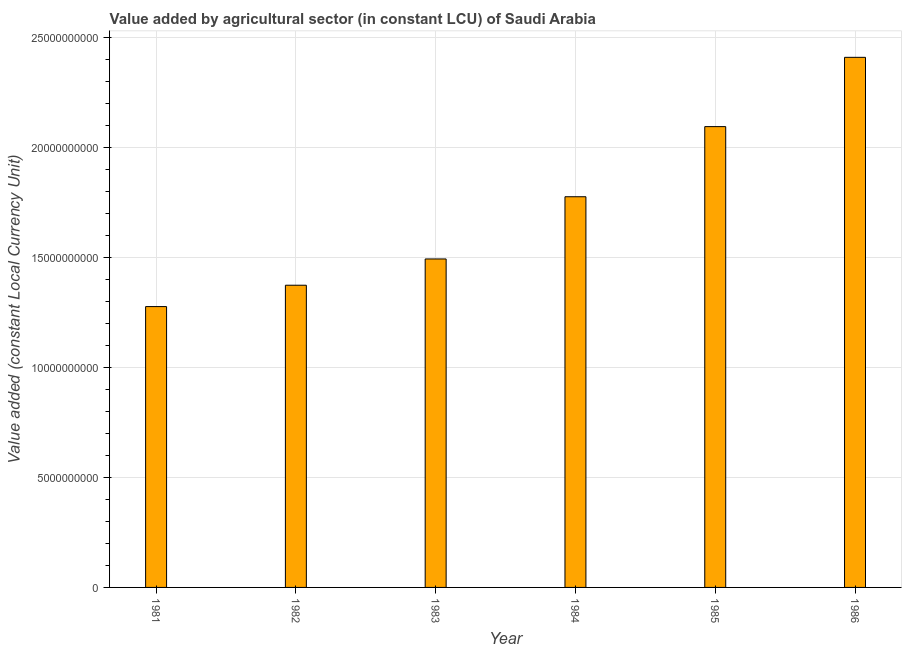Does the graph contain any zero values?
Provide a short and direct response. No. What is the title of the graph?
Provide a short and direct response. Value added by agricultural sector (in constant LCU) of Saudi Arabia. What is the label or title of the Y-axis?
Your response must be concise. Value added (constant Local Currency Unit). What is the value added by agriculture sector in 1981?
Offer a terse response. 1.28e+1. Across all years, what is the maximum value added by agriculture sector?
Keep it short and to the point. 2.41e+1. Across all years, what is the minimum value added by agriculture sector?
Provide a short and direct response. 1.28e+1. In which year was the value added by agriculture sector minimum?
Keep it short and to the point. 1981. What is the sum of the value added by agriculture sector?
Your answer should be very brief. 1.04e+11. What is the difference between the value added by agriculture sector in 1984 and 1985?
Your response must be concise. -3.19e+09. What is the average value added by agriculture sector per year?
Your response must be concise. 1.74e+1. What is the median value added by agriculture sector?
Provide a succinct answer. 1.63e+1. In how many years, is the value added by agriculture sector greater than 16000000000 LCU?
Provide a short and direct response. 3. What is the ratio of the value added by agriculture sector in 1983 to that in 1984?
Provide a short and direct response. 0.84. Is the difference between the value added by agriculture sector in 1981 and 1986 greater than the difference between any two years?
Offer a terse response. Yes. What is the difference between the highest and the second highest value added by agriculture sector?
Your answer should be very brief. 3.15e+09. Is the sum of the value added by agriculture sector in 1981 and 1982 greater than the maximum value added by agriculture sector across all years?
Provide a short and direct response. Yes. What is the difference between the highest and the lowest value added by agriculture sector?
Your answer should be very brief. 1.13e+1. How many bars are there?
Give a very brief answer. 6. What is the difference between two consecutive major ticks on the Y-axis?
Make the answer very short. 5.00e+09. What is the Value added (constant Local Currency Unit) in 1981?
Offer a very short reply. 1.28e+1. What is the Value added (constant Local Currency Unit) in 1982?
Ensure brevity in your answer.  1.37e+1. What is the Value added (constant Local Currency Unit) in 1983?
Your answer should be very brief. 1.49e+1. What is the Value added (constant Local Currency Unit) of 1984?
Your answer should be compact. 1.78e+1. What is the Value added (constant Local Currency Unit) in 1985?
Offer a terse response. 2.09e+1. What is the Value added (constant Local Currency Unit) of 1986?
Your answer should be very brief. 2.41e+1. What is the difference between the Value added (constant Local Currency Unit) in 1981 and 1982?
Your answer should be very brief. -9.70e+08. What is the difference between the Value added (constant Local Currency Unit) in 1981 and 1983?
Offer a terse response. -2.16e+09. What is the difference between the Value added (constant Local Currency Unit) in 1981 and 1984?
Give a very brief answer. -4.99e+09. What is the difference between the Value added (constant Local Currency Unit) in 1981 and 1985?
Your response must be concise. -8.18e+09. What is the difference between the Value added (constant Local Currency Unit) in 1981 and 1986?
Provide a short and direct response. -1.13e+1. What is the difference between the Value added (constant Local Currency Unit) in 1982 and 1983?
Keep it short and to the point. -1.19e+09. What is the difference between the Value added (constant Local Currency Unit) in 1982 and 1984?
Provide a succinct answer. -4.02e+09. What is the difference between the Value added (constant Local Currency Unit) in 1982 and 1985?
Your answer should be very brief. -7.21e+09. What is the difference between the Value added (constant Local Currency Unit) in 1982 and 1986?
Provide a short and direct response. -1.04e+1. What is the difference between the Value added (constant Local Currency Unit) in 1983 and 1984?
Keep it short and to the point. -2.83e+09. What is the difference between the Value added (constant Local Currency Unit) in 1983 and 1985?
Your response must be concise. -6.01e+09. What is the difference between the Value added (constant Local Currency Unit) in 1983 and 1986?
Give a very brief answer. -9.16e+09. What is the difference between the Value added (constant Local Currency Unit) in 1984 and 1985?
Offer a terse response. -3.19e+09. What is the difference between the Value added (constant Local Currency Unit) in 1984 and 1986?
Your answer should be compact. -6.33e+09. What is the difference between the Value added (constant Local Currency Unit) in 1985 and 1986?
Your response must be concise. -3.15e+09. What is the ratio of the Value added (constant Local Currency Unit) in 1981 to that in 1982?
Your answer should be very brief. 0.93. What is the ratio of the Value added (constant Local Currency Unit) in 1981 to that in 1983?
Make the answer very short. 0.85. What is the ratio of the Value added (constant Local Currency Unit) in 1981 to that in 1984?
Give a very brief answer. 0.72. What is the ratio of the Value added (constant Local Currency Unit) in 1981 to that in 1985?
Ensure brevity in your answer.  0.61. What is the ratio of the Value added (constant Local Currency Unit) in 1981 to that in 1986?
Your response must be concise. 0.53. What is the ratio of the Value added (constant Local Currency Unit) in 1982 to that in 1984?
Provide a succinct answer. 0.77. What is the ratio of the Value added (constant Local Currency Unit) in 1982 to that in 1985?
Make the answer very short. 0.66. What is the ratio of the Value added (constant Local Currency Unit) in 1982 to that in 1986?
Provide a short and direct response. 0.57. What is the ratio of the Value added (constant Local Currency Unit) in 1983 to that in 1984?
Your answer should be compact. 0.84. What is the ratio of the Value added (constant Local Currency Unit) in 1983 to that in 1985?
Your response must be concise. 0.71. What is the ratio of the Value added (constant Local Currency Unit) in 1983 to that in 1986?
Keep it short and to the point. 0.62. What is the ratio of the Value added (constant Local Currency Unit) in 1984 to that in 1985?
Keep it short and to the point. 0.85. What is the ratio of the Value added (constant Local Currency Unit) in 1984 to that in 1986?
Your answer should be compact. 0.74. What is the ratio of the Value added (constant Local Currency Unit) in 1985 to that in 1986?
Provide a short and direct response. 0.87. 